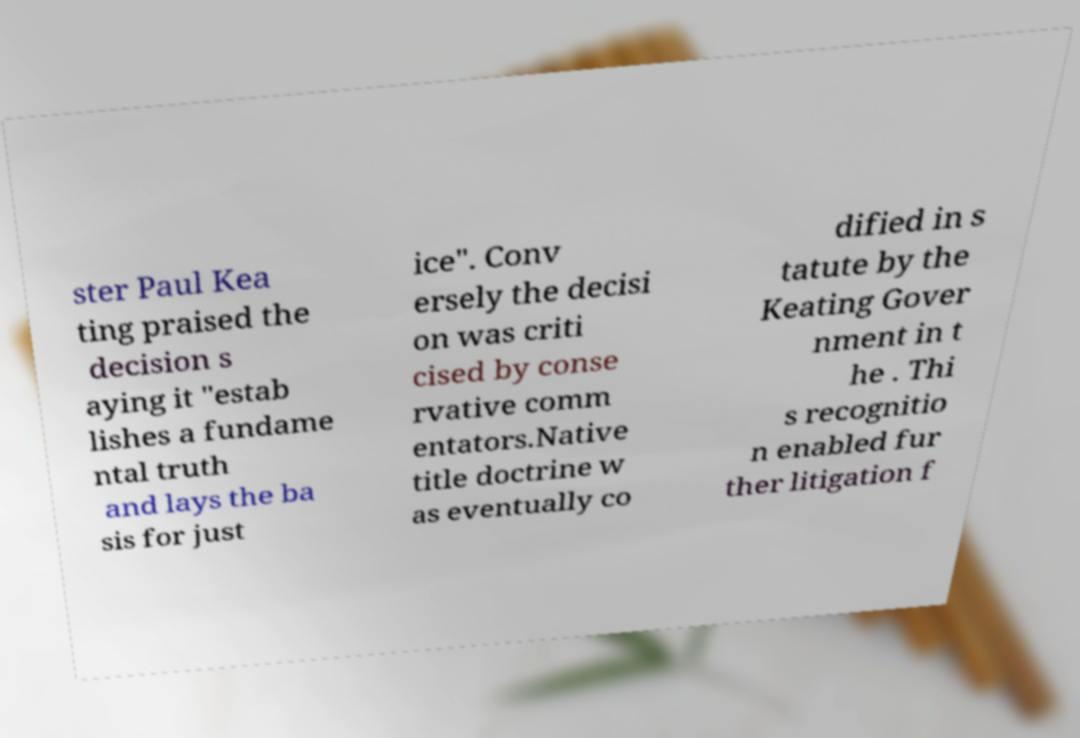For documentation purposes, I need the text within this image transcribed. Could you provide that? ster Paul Kea ting praised the decision s aying it "estab lishes a fundame ntal truth and lays the ba sis for just ice". Conv ersely the decisi on was criti cised by conse rvative comm entators.Native title doctrine w as eventually co dified in s tatute by the Keating Gover nment in t he . Thi s recognitio n enabled fur ther litigation f 